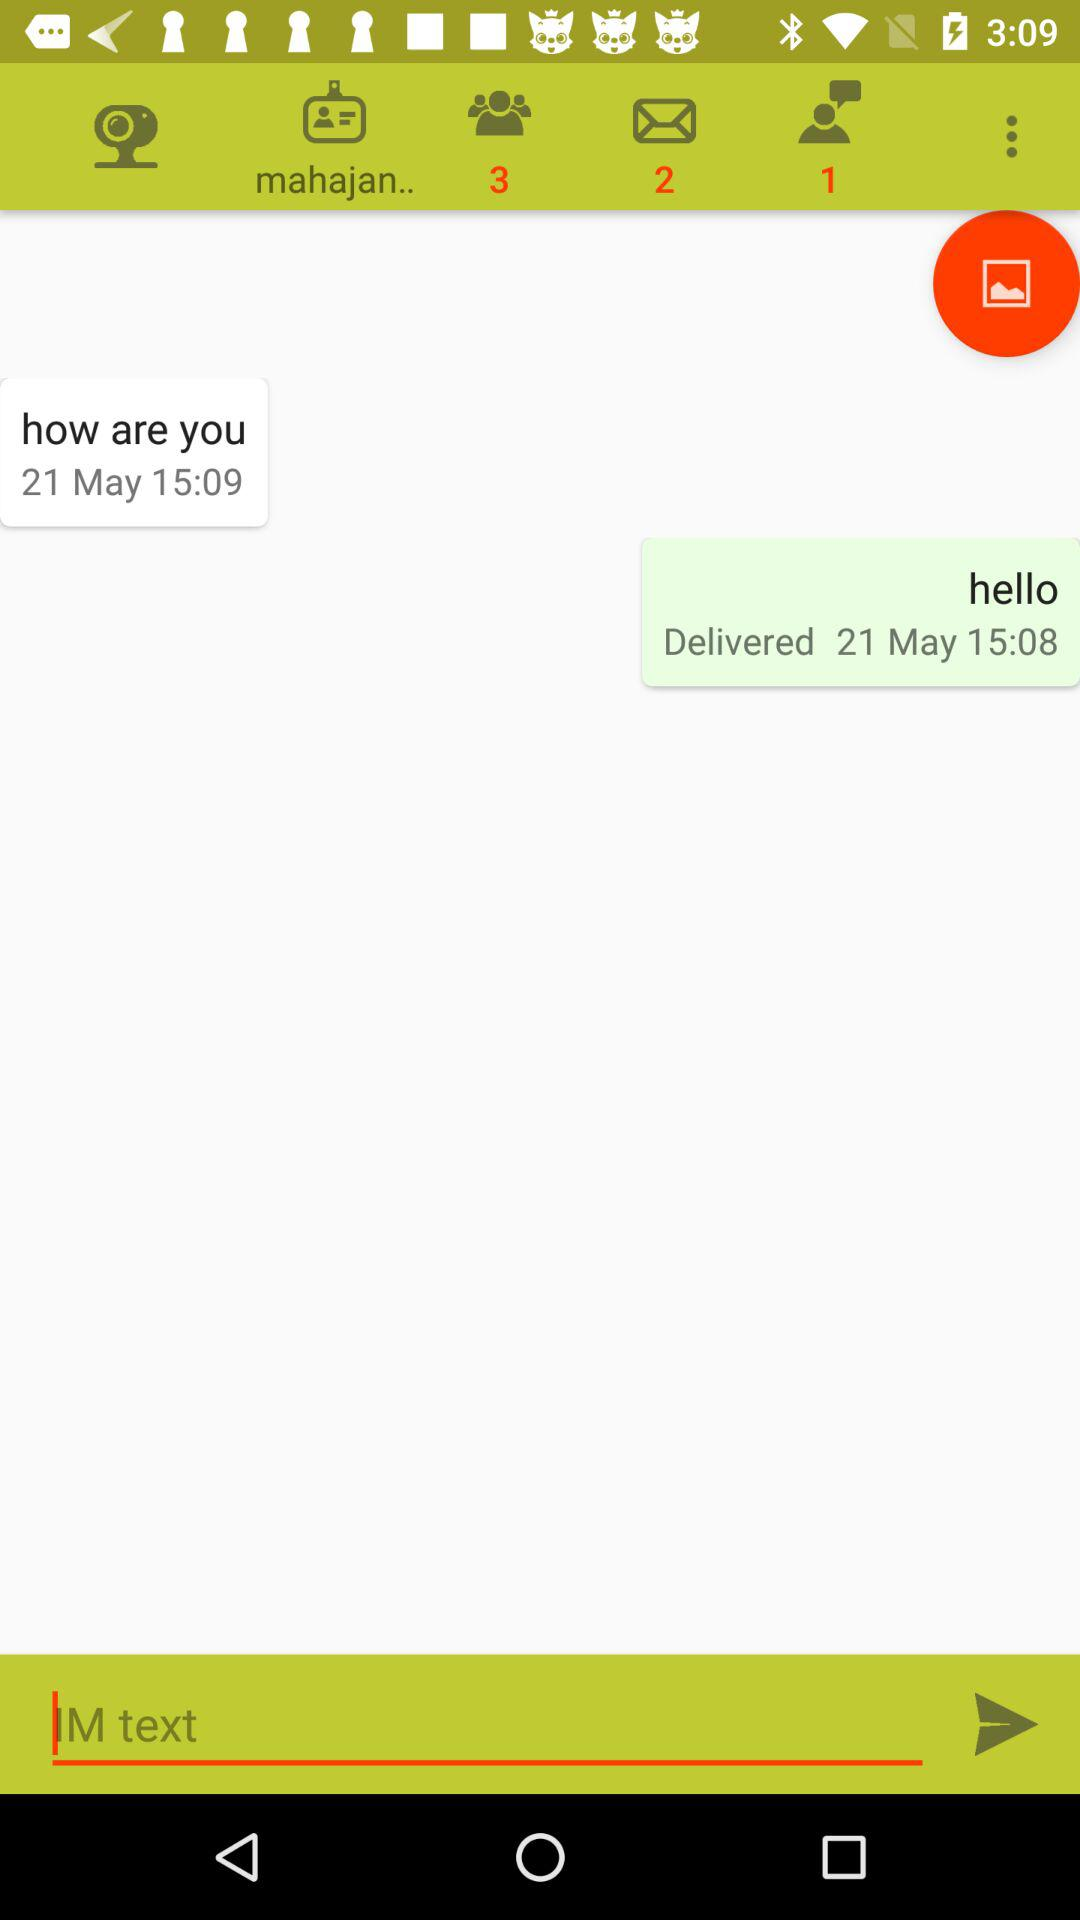How many unread messages are there in the group? There are 3 unread messages. 